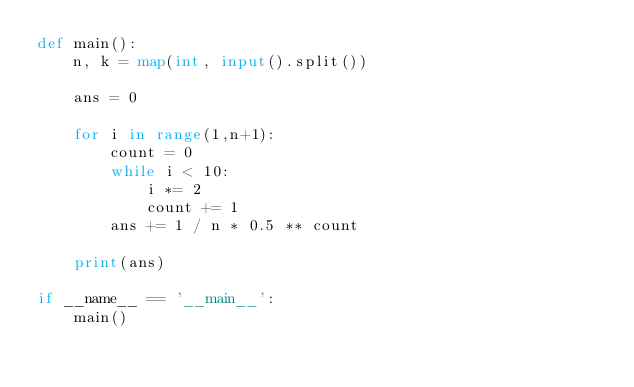<code> <loc_0><loc_0><loc_500><loc_500><_Python_>def main():
    n, k = map(int, input().split())

    ans = 0

    for i in range(1,n+1):
        count = 0
        while i < 10:
            i *= 2
            count += 1
        ans += 1 / n * 0.5 ** count
        
    print(ans)

if __name__ == '__main__':
    main()</code> 